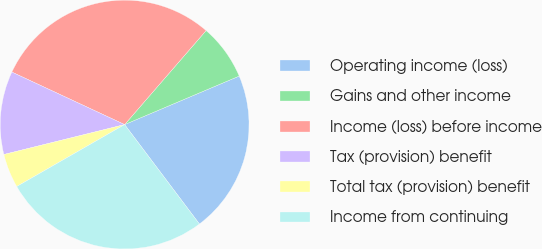Convert chart to OTSL. <chart><loc_0><loc_0><loc_500><loc_500><pie_chart><fcel>Operating income (loss)<fcel>Gains and other income<fcel>Income (loss) before income<fcel>Tax (provision) benefit<fcel>Total tax (provision) benefit<fcel>Income from continuing<nl><fcel>21.11%<fcel>7.26%<fcel>29.43%<fcel>10.8%<fcel>4.43%<fcel>26.97%<nl></chart> 